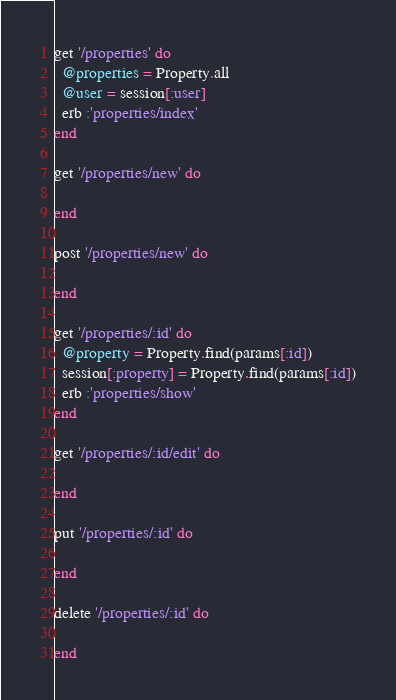Convert code to text. <code><loc_0><loc_0><loc_500><loc_500><_Ruby_>get '/properties' do
  @properties = Property.all
  @user = session[:user]
  erb :'properties/index'
end

get '/properties/new' do

end

post '/properties/new' do

end

get '/properties/:id' do
  @property = Property.find(params[:id])
  session[:property] = Property.find(params[:id])
  erb :'properties/show'
end

get '/properties/:id/edit' do

end

put '/properties/:id' do

end

delete '/properties/:id' do

end</code> 